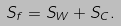Convert formula to latex. <formula><loc_0><loc_0><loc_500><loc_500>S _ { f } = S _ { W } + S _ { C } .</formula> 